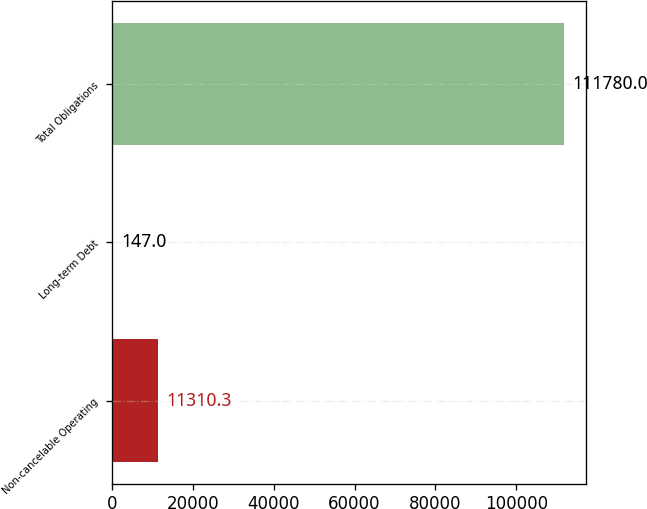Convert chart to OTSL. <chart><loc_0><loc_0><loc_500><loc_500><bar_chart><fcel>Non-cancelable Operating<fcel>Long-term Debt<fcel>Total Obligations<nl><fcel>11310.3<fcel>147<fcel>111780<nl></chart> 